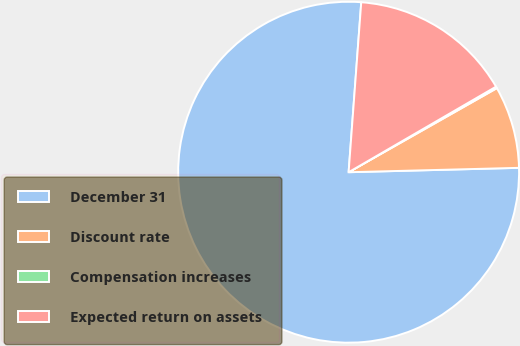Convert chart. <chart><loc_0><loc_0><loc_500><loc_500><pie_chart><fcel>December 31<fcel>Discount rate<fcel>Compensation increases<fcel>Expected return on assets<nl><fcel>76.59%<fcel>7.8%<fcel>0.16%<fcel>15.45%<nl></chart> 